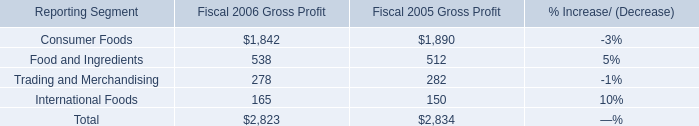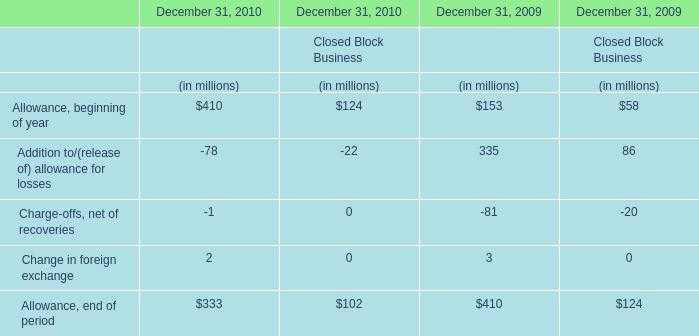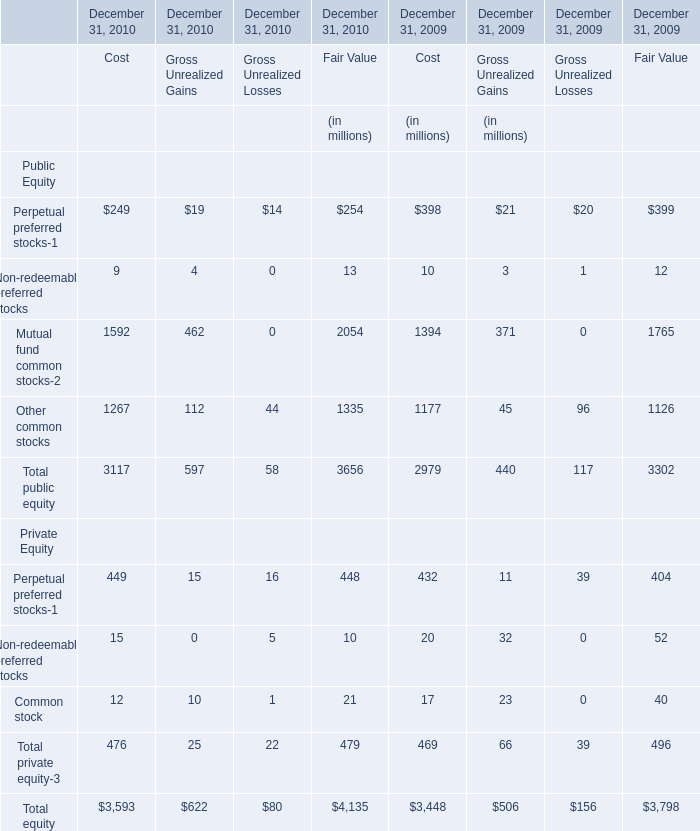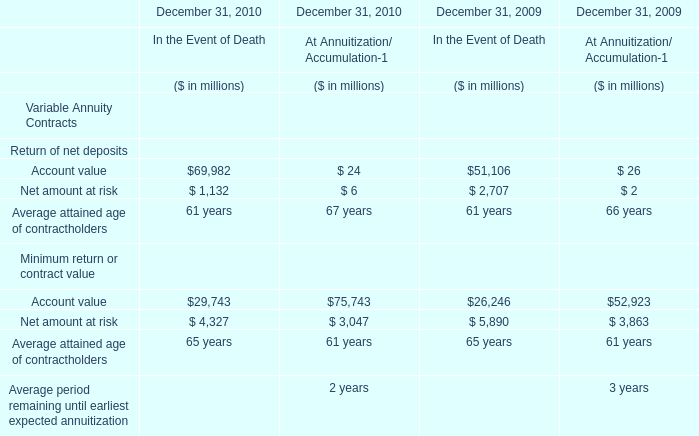What is the increasing rate of Gross Unrealized Gains for Total public equity on December 31 in 2010？ 
Computations: ((597 - 440) / 440)
Answer: 0.35682. 